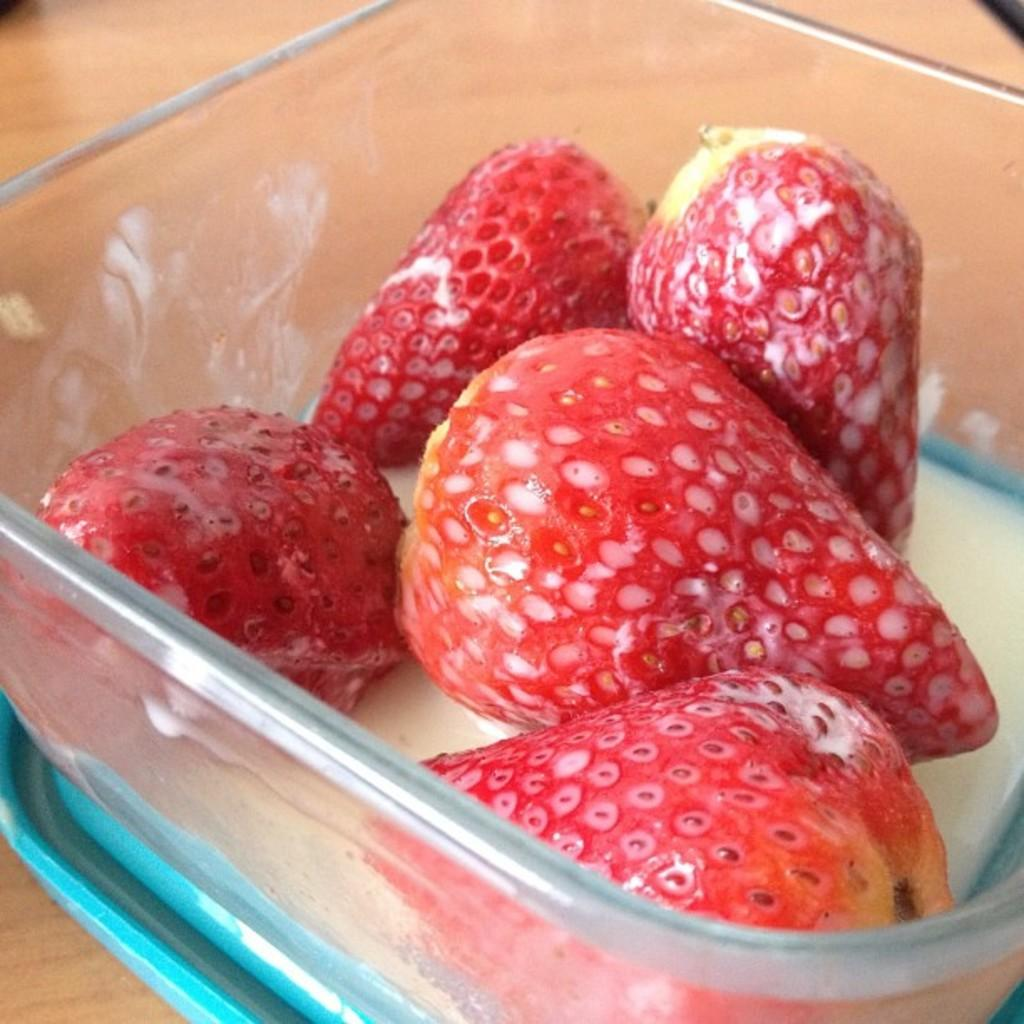What is the main object in the image? There is a strawberry container in the image. Can you describe the container in more detail? The container is designed to hold strawberries, likely for storage or transportation. What might be the purpose of this container? The container's purpose is to keep strawberries fresh and organized. What type of harmony is being played by the strawberries in the container? There is no harmony being played by the strawberries in the container, as they are inanimate objects and cannot produce music. 